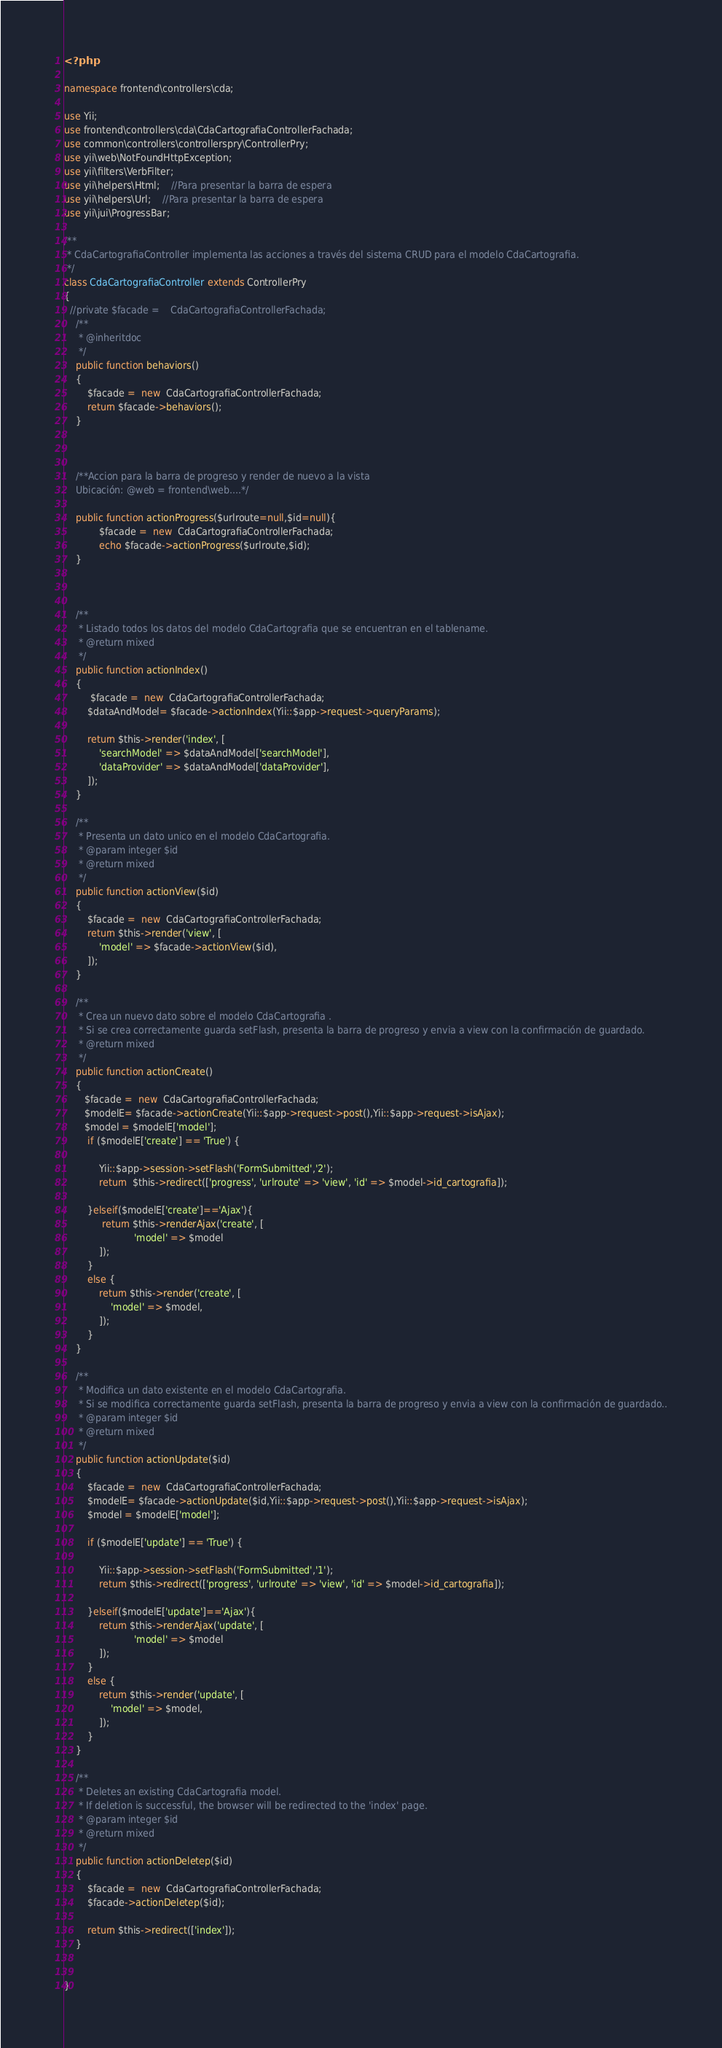<code> <loc_0><loc_0><loc_500><loc_500><_PHP_><?php

namespace frontend\controllers\cda;

use Yii;
use frontend\controllers\cda\CdaCartografiaControllerFachada;
use common\controllers\controllerspry\ControllerPry;
use yii\web\NotFoundHttpException;
use yii\filters\VerbFilter;
use yii\helpers\Html;	//Para presentar la barra de espera
use yii\helpers\Url;	//Para presentar la barra de espera
use yii\jui\ProgressBar;

/**
 * CdaCartografiaController implementa las acciones a través del sistema CRUD para el modelo CdaCartografia.
 */
class CdaCartografiaController extends ControllerPry
{
  //private $facade =    CdaCartografiaControllerFachada;
    /**
     * @inheritdoc
     */
    public function behaviors()
    {
        $facade =  new  CdaCartografiaControllerFachada;
        return $facade->behaviors();
    }
	
    
	
    /**Accion para la barra de progreso y render de nuevo a la vista
    Ubicación: @web = frontend\web....*/

    public function actionProgress($urlroute=null,$id=null){
            $facade =  new  CdaCartografiaControllerFachada;
            echo $facade->actionProgress($urlroute,$id);
    }

	
	
    /**
     * Listado todos los datos del modelo CdaCartografia que se encuentran en el tablename.
     * @return mixed
     */
    public function actionIndex()
    {
         $facade =  new  CdaCartografiaControllerFachada;
        $dataAndModel= $facade->actionIndex(Yii::$app->request->queryParams);
        
        return $this->render('index', [
            'searchModel' => $dataAndModel['searchModel'],
            'dataProvider' => $dataAndModel['dataProvider'],
        ]);
    }

    /**
     * Presenta un dato unico en el modelo CdaCartografia.
     * @param integer $id
     * @return mixed
     */
    public function actionView($id)
    {
        $facade =  new  CdaCartografiaControllerFachada;
        return $this->render('view', [
            'model' => $facade->actionView($id),
        ]);
    }

    /**
     * Crea un nuevo dato sobre el modelo CdaCartografia .
     * Si se crea correctamente guarda setFlash, presenta la barra de progreso y envia a view con la confirmación de guardado.
     * @return mixed
     */
    public function actionCreate()
    {
       $facade =  new  CdaCartografiaControllerFachada;
       $modelE= $facade->actionCreate(Yii::$app->request->post(),Yii::$app->request->isAjax);
       $model = $modelE['model'];
        if ($modelE['create'] == 'True') {
			
            Yii::$app->session->setFlash('FormSubmitted','2');
            return  $this->redirect(['progress', 'urlroute' => 'view', 'id' => $model->id_cartografia]);		
			
        }elseif($modelE['create']=='Ajax'){
             return $this->renderAjax('create', [
                        'model' => $model
            ]);
        } 
        else {
            return $this->render('create', [
                'model' => $model,
            ]);
        }
    }

    /**
     * Modifica un dato existente en el modelo CdaCartografia.
     * Si se modifica correctamente guarda setFlash, presenta la barra de progreso y envia a view con la confirmación de guardado..
     * @param integer $id
     * @return mixed
     */
    public function actionUpdate($id)
    {
        $facade =  new  CdaCartografiaControllerFachada;
        $modelE= $facade->actionUpdate($id,Yii::$app->request->post(),Yii::$app->request->isAjax);
        $model = $modelE['model'];

        if ($modelE['update'] == 'True') {
            
            Yii::$app->session->setFlash('FormSubmitted','1');		
            return $this->redirect(['progress', 'urlroute' => 'view', 'id' => $model->id_cartografia]);
            
        }elseif($modelE['update']=='Ajax'){
            return $this->renderAjax('update', [
                        'model' => $model
            ]);
        } 
        else {
            return $this->render('update', [
                'model' => $model,
            ]);
        }
    }

    /**
     * Deletes an existing CdaCartografia model.
     * If deletion is successful, the browser will be redirected to the 'index' page.
     * @param integer $id
     * @return mixed
     */
    public function actionDeletep($id)
    {
        $facade =  new  CdaCartografiaControllerFachada;
        $facade->actionDeletep($id);

        return $this->redirect(['index']);
    }

    
}
</code> 